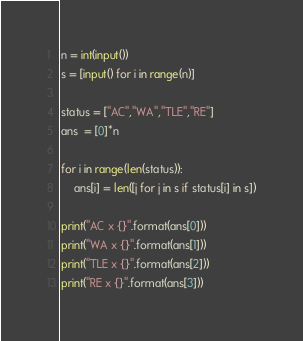Convert code to text. <code><loc_0><loc_0><loc_500><loc_500><_Python_>n = int(input())
s = [input() for i in range(n)]

status = ["AC","WA","TLE","RE"]
ans  = [0]*n

for i in range(len(status)):
    ans[i] = len([j for j in s if status[i] in s])

print("AC x {}".format(ans[0]))
print("WA x {}".format(ans[1]))
print("TLE x {}".format(ans[2]))
print("RE x {}".format(ans[3]))
</code> 